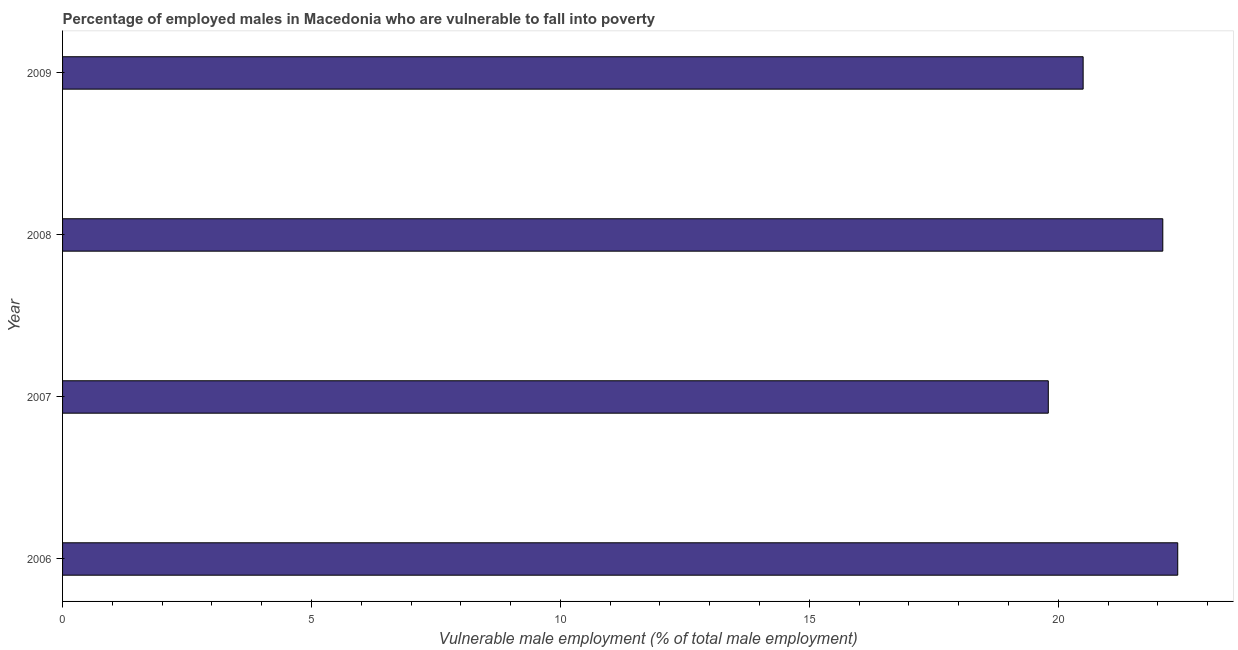Does the graph contain any zero values?
Your response must be concise. No. What is the title of the graph?
Make the answer very short. Percentage of employed males in Macedonia who are vulnerable to fall into poverty. What is the label or title of the X-axis?
Offer a terse response. Vulnerable male employment (% of total male employment). What is the percentage of employed males who are vulnerable to fall into poverty in 2008?
Your answer should be compact. 22.1. Across all years, what is the maximum percentage of employed males who are vulnerable to fall into poverty?
Give a very brief answer. 22.4. Across all years, what is the minimum percentage of employed males who are vulnerable to fall into poverty?
Offer a terse response. 19.8. What is the sum of the percentage of employed males who are vulnerable to fall into poverty?
Give a very brief answer. 84.8. What is the average percentage of employed males who are vulnerable to fall into poverty per year?
Keep it short and to the point. 21.2. What is the median percentage of employed males who are vulnerable to fall into poverty?
Give a very brief answer. 21.3. In how many years, is the percentage of employed males who are vulnerable to fall into poverty greater than 18 %?
Provide a succinct answer. 4. Is the percentage of employed males who are vulnerable to fall into poverty in 2007 less than that in 2009?
Give a very brief answer. Yes. Is the sum of the percentage of employed males who are vulnerable to fall into poverty in 2007 and 2008 greater than the maximum percentage of employed males who are vulnerable to fall into poverty across all years?
Keep it short and to the point. Yes. What is the difference between the highest and the lowest percentage of employed males who are vulnerable to fall into poverty?
Offer a very short reply. 2.6. In how many years, is the percentage of employed males who are vulnerable to fall into poverty greater than the average percentage of employed males who are vulnerable to fall into poverty taken over all years?
Your answer should be very brief. 2. How many bars are there?
Your answer should be compact. 4. Are all the bars in the graph horizontal?
Keep it short and to the point. Yes. How many years are there in the graph?
Offer a very short reply. 4. Are the values on the major ticks of X-axis written in scientific E-notation?
Provide a short and direct response. No. What is the Vulnerable male employment (% of total male employment) in 2006?
Offer a terse response. 22.4. What is the Vulnerable male employment (% of total male employment) of 2007?
Keep it short and to the point. 19.8. What is the Vulnerable male employment (% of total male employment) of 2008?
Provide a succinct answer. 22.1. What is the Vulnerable male employment (% of total male employment) of 2009?
Ensure brevity in your answer.  20.5. What is the difference between the Vulnerable male employment (% of total male employment) in 2006 and 2007?
Offer a terse response. 2.6. What is the difference between the Vulnerable male employment (% of total male employment) in 2006 and 2009?
Ensure brevity in your answer.  1.9. What is the difference between the Vulnerable male employment (% of total male employment) in 2007 and 2008?
Your answer should be very brief. -2.3. What is the difference between the Vulnerable male employment (% of total male employment) in 2007 and 2009?
Offer a terse response. -0.7. What is the difference between the Vulnerable male employment (% of total male employment) in 2008 and 2009?
Provide a succinct answer. 1.6. What is the ratio of the Vulnerable male employment (% of total male employment) in 2006 to that in 2007?
Provide a succinct answer. 1.13. What is the ratio of the Vulnerable male employment (% of total male employment) in 2006 to that in 2008?
Your response must be concise. 1.01. What is the ratio of the Vulnerable male employment (% of total male employment) in 2006 to that in 2009?
Offer a very short reply. 1.09. What is the ratio of the Vulnerable male employment (% of total male employment) in 2007 to that in 2008?
Your answer should be compact. 0.9. What is the ratio of the Vulnerable male employment (% of total male employment) in 2007 to that in 2009?
Give a very brief answer. 0.97. What is the ratio of the Vulnerable male employment (% of total male employment) in 2008 to that in 2009?
Keep it short and to the point. 1.08. 